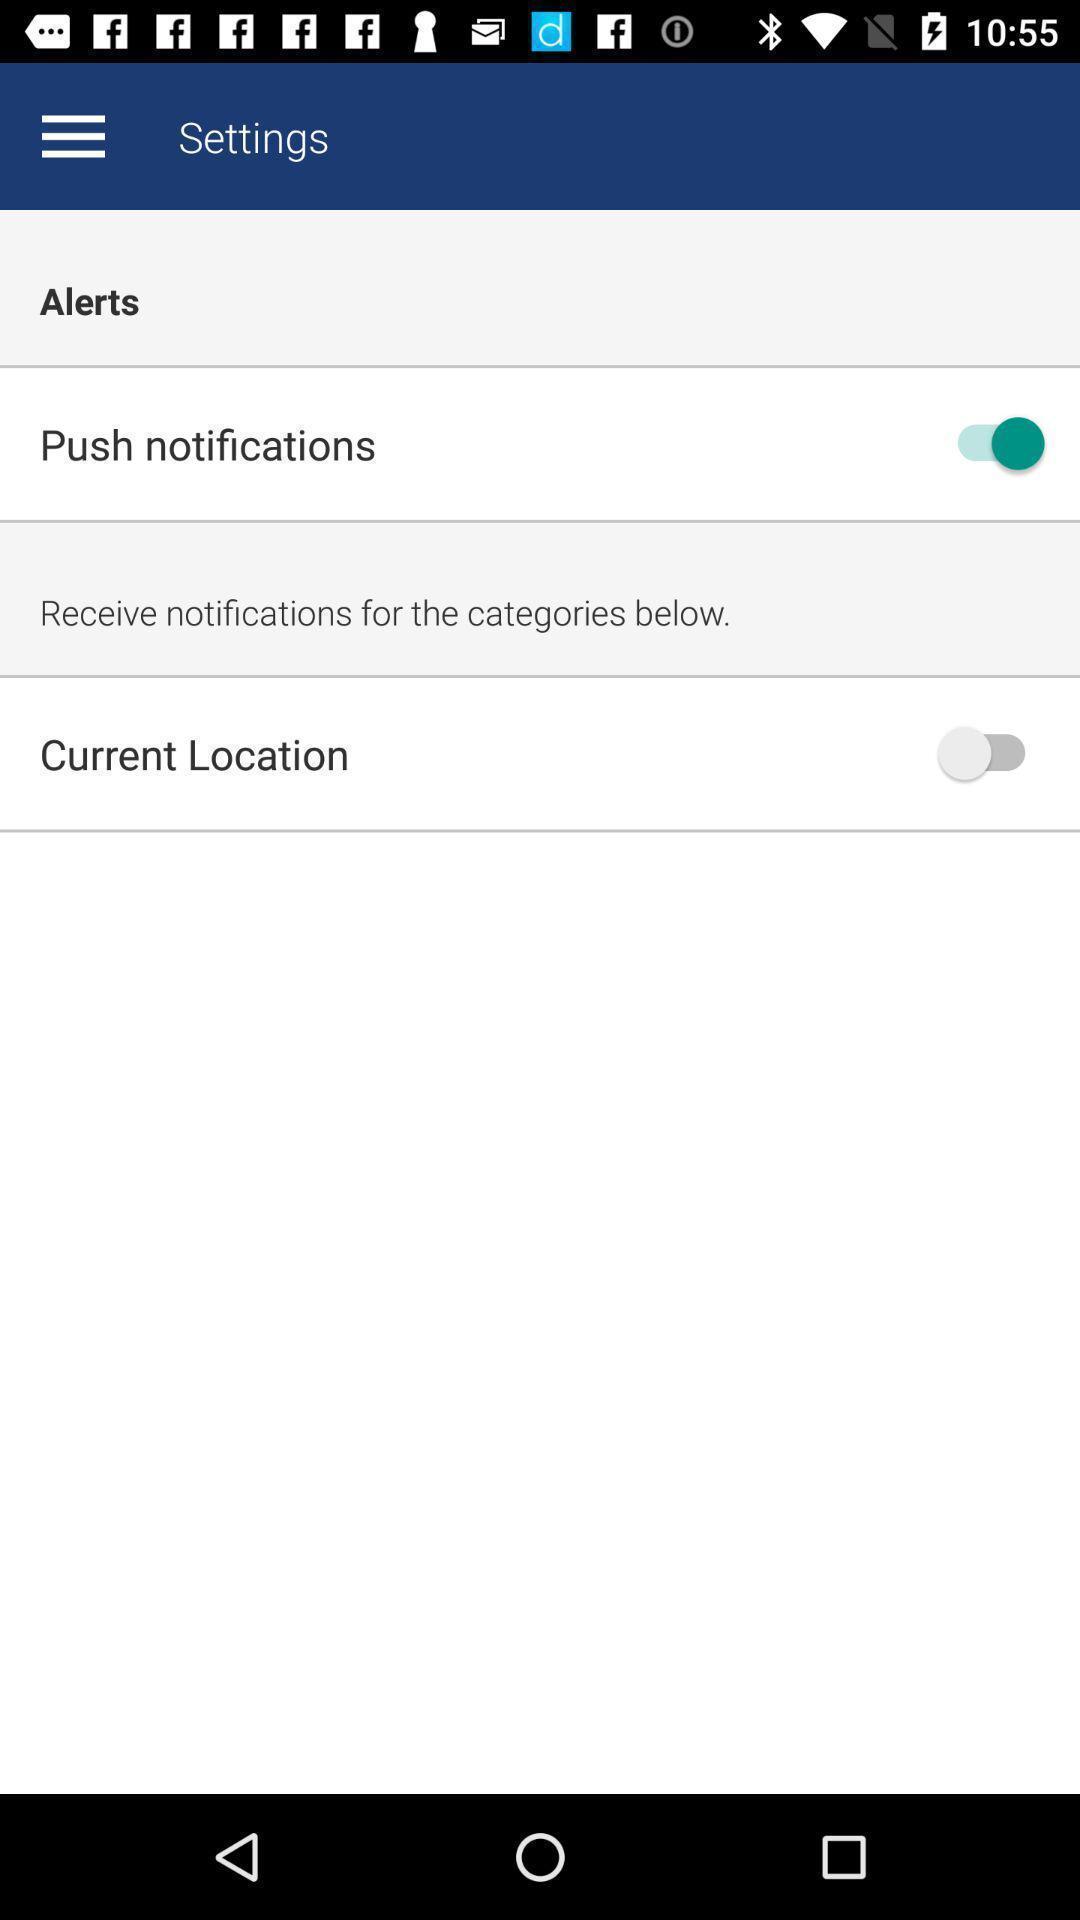Tell me about the visual elements in this screen capture. Screen showing options in settings. 